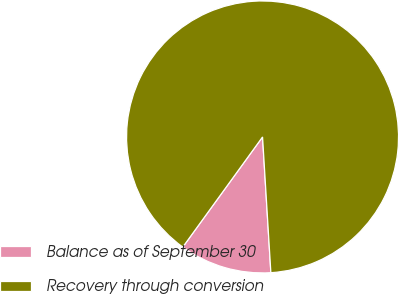<chart> <loc_0><loc_0><loc_500><loc_500><pie_chart><fcel>Balance as of September 30<fcel>Recovery through conversion<nl><fcel>10.95%<fcel>89.05%<nl></chart> 